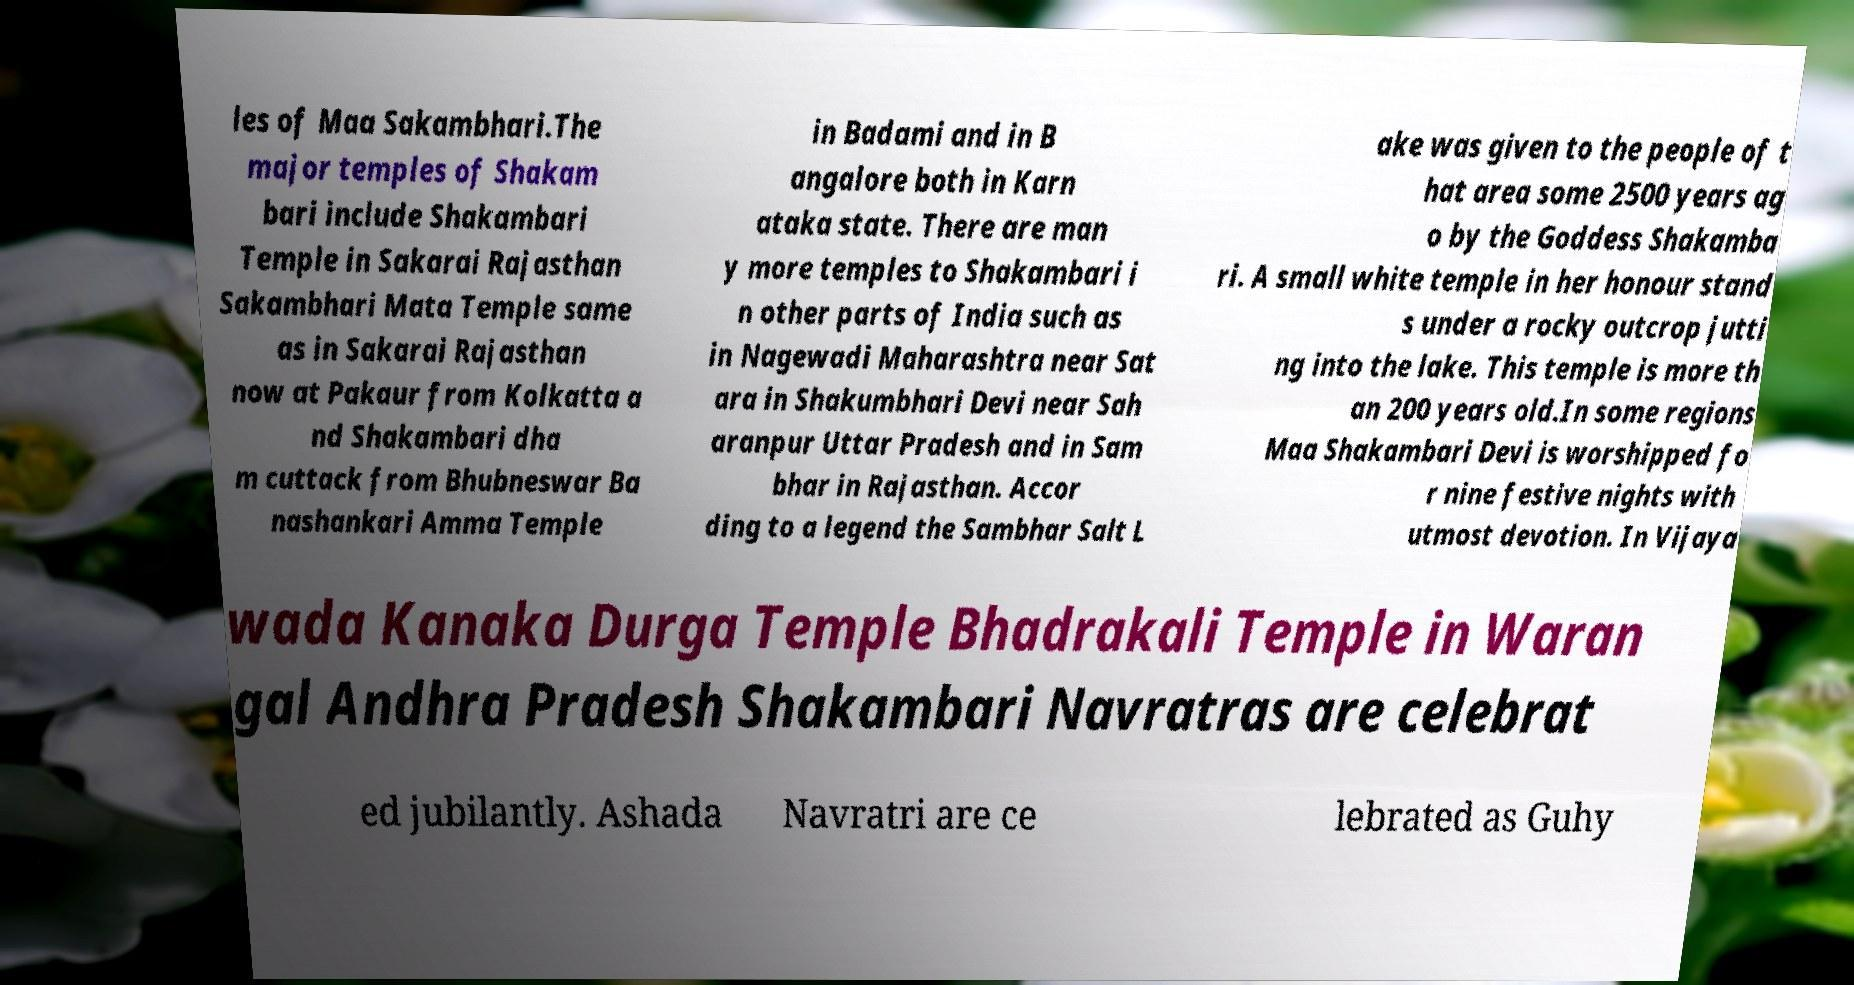For documentation purposes, I need the text within this image transcribed. Could you provide that? les of Maa Sakambhari.The major temples of Shakam bari include Shakambari Temple in Sakarai Rajasthan Sakambhari Mata Temple same as in Sakarai Rajasthan now at Pakaur from Kolkatta a nd Shakambari dha m cuttack from Bhubneswar Ba nashankari Amma Temple in Badami and in B angalore both in Karn ataka state. There are man y more temples to Shakambari i n other parts of India such as in Nagewadi Maharashtra near Sat ara in Shakumbhari Devi near Sah aranpur Uttar Pradesh and in Sam bhar in Rajasthan. Accor ding to a legend the Sambhar Salt L ake was given to the people of t hat area some 2500 years ag o by the Goddess Shakamba ri. A small white temple in her honour stand s under a rocky outcrop jutti ng into the lake. This temple is more th an 200 years old.In some regions Maa Shakambari Devi is worshipped fo r nine festive nights with utmost devotion. In Vijaya wada Kanaka Durga Temple Bhadrakali Temple in Waran gal Andhra Pradesh Shakambari Navratras are celebrat ed jubilantly. Ashada Navratri are ce lebrated as Guhy 